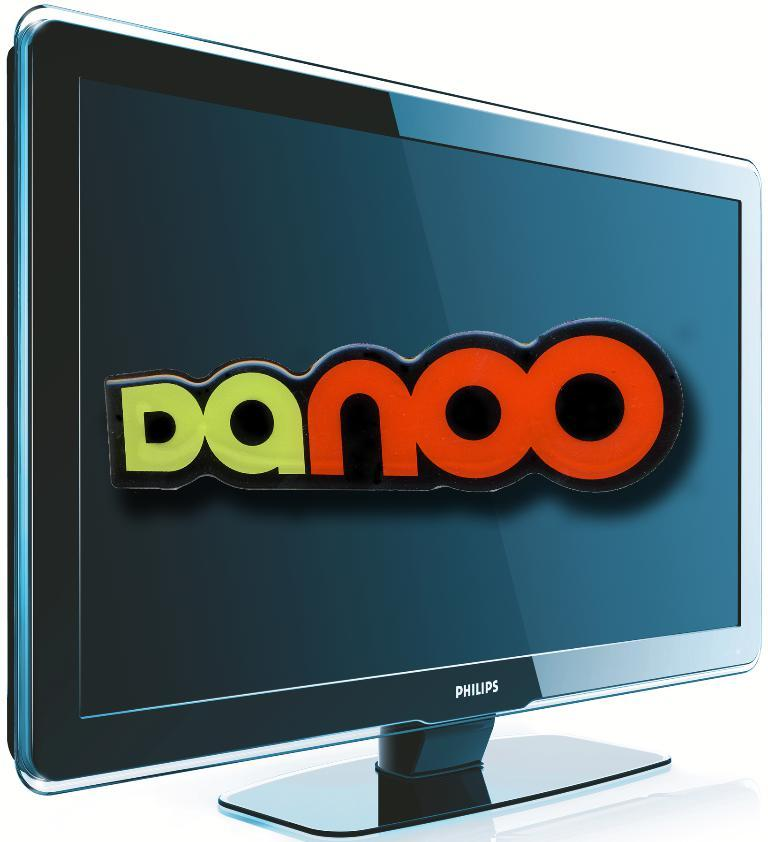<image>
Render a clear and concise summary of the photo. Computer monitor by Philips that says "Danoo" on it. 